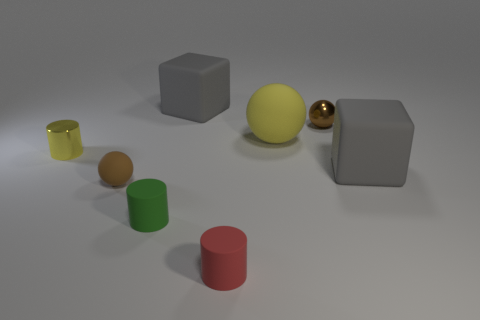Add 2 shiny objects. How many objects exist? 10 Subtract all blocks. How many objects are left? 6 Add 1 green things. How many green things are left? 2 Add 6 red metal cylinders. How many red metal cylinders exist? 6 Subtract 0 yellow blocks. How many objects are left? 8 Subtract all cylinders. Subtract all red shiny cylinders. How many objects are left? 5 